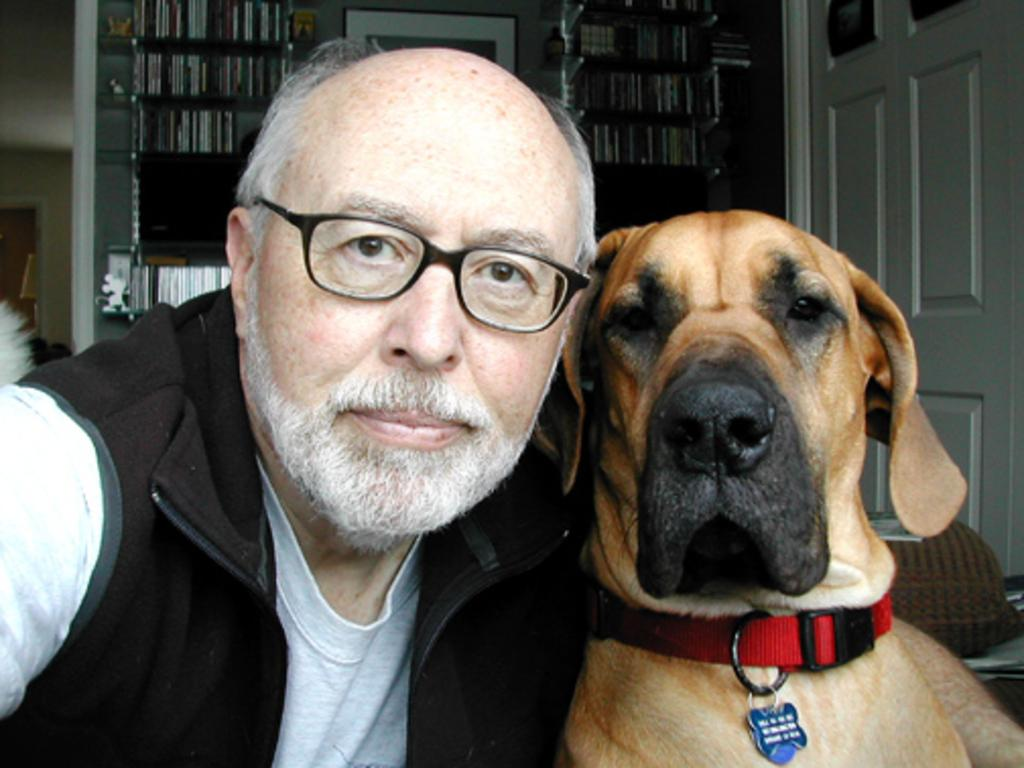Who is present in the image? There is a man and a dog in the image. What can be seen in the background of the image? The books are arranged in a shell in the background of the image. What hobbies does the dog have in the image? The image does not provide information about the dog's hobbies, as it only shows the dog's presence and not its activities or interests. 